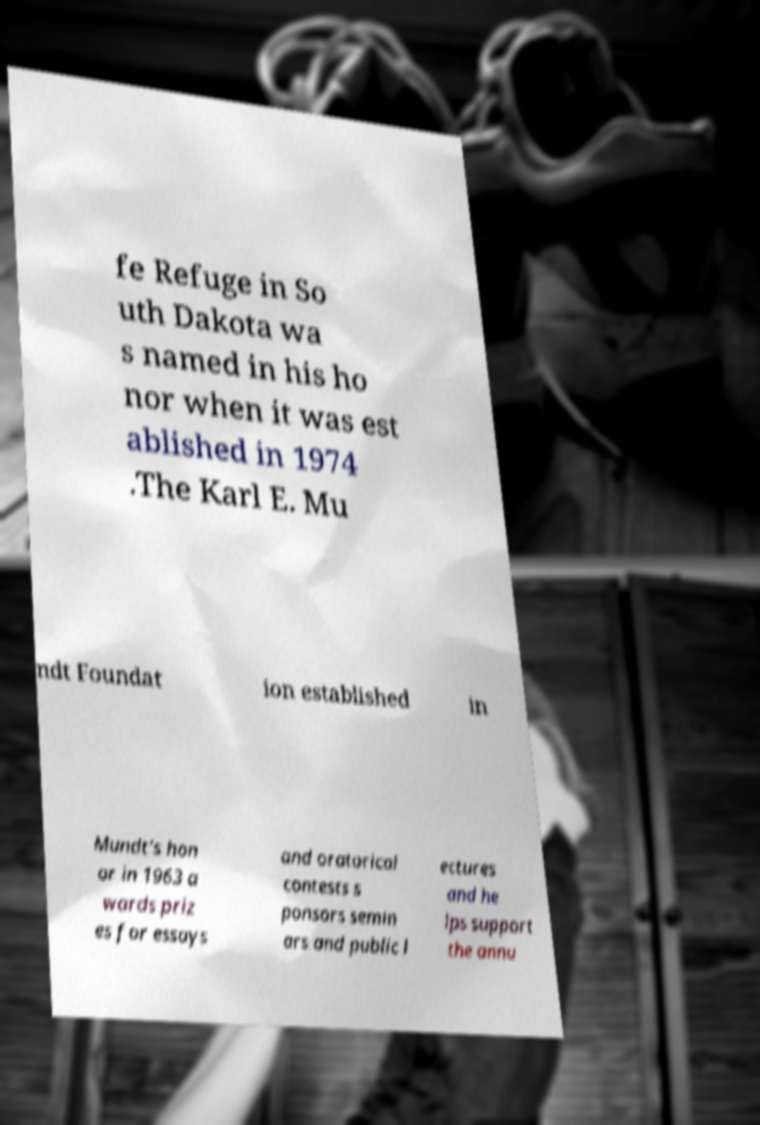What messages or text are displayed in this image? I need them in a readable, typed format. fe Refuge in So uth Dakota wa s named in his ho nor when it was est ablished in 1974 .The Karl E. Mu ndt Foundat ion established in Mundt's hon or in 1963 a wards priz es for essays and oratorical contests s ponsors semin ars and public l ectures and he lps support the annu 